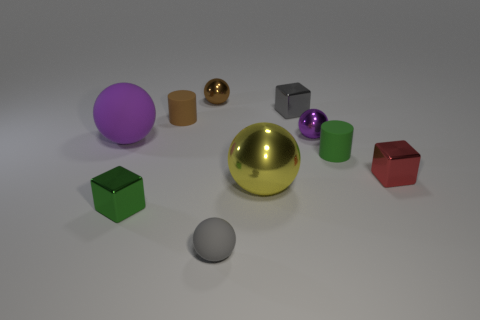How many tiny spheres have the same color as the big rubber sphere?
Give a very brief answer. 1. There is a object that is in front of the yellow shiny ball and to the right of the tiny brown ball; what is its color?
Make the answer very short. Gray. What number of things are large purple matte balls or tiny metal objects that are left of the large metallic sphere?
Provide a short and direct response. 3. There is a tiny cylinder that is to the left of the green thing to the right of the purple thing that is to the right of the brown metallic thing; what is it made of?
Provide a short and direct response. Rubber. Is there anything else that is the same material as the tiny gray block?
Your response must be concise. Yes. There is a cube that is left of the small gray rubber object; does it have the same color as the big rubber thing?
Your answer should be very brief. No. What number of gray things are either tiny balls or tiny shiny balls?
Your answer should be very brief. 1. How many other things are there of the same shape as the gray shiny thing?
Your answer should be very brief. 2. Are the small purple object and the brown cylinder made of the same material?
Offer a very short reply. No. There is a ball that is both left of the gray matte sphere and on the right side of the purple matte thing; what material is it?
Ensure brevity in your answer.  Metal. 